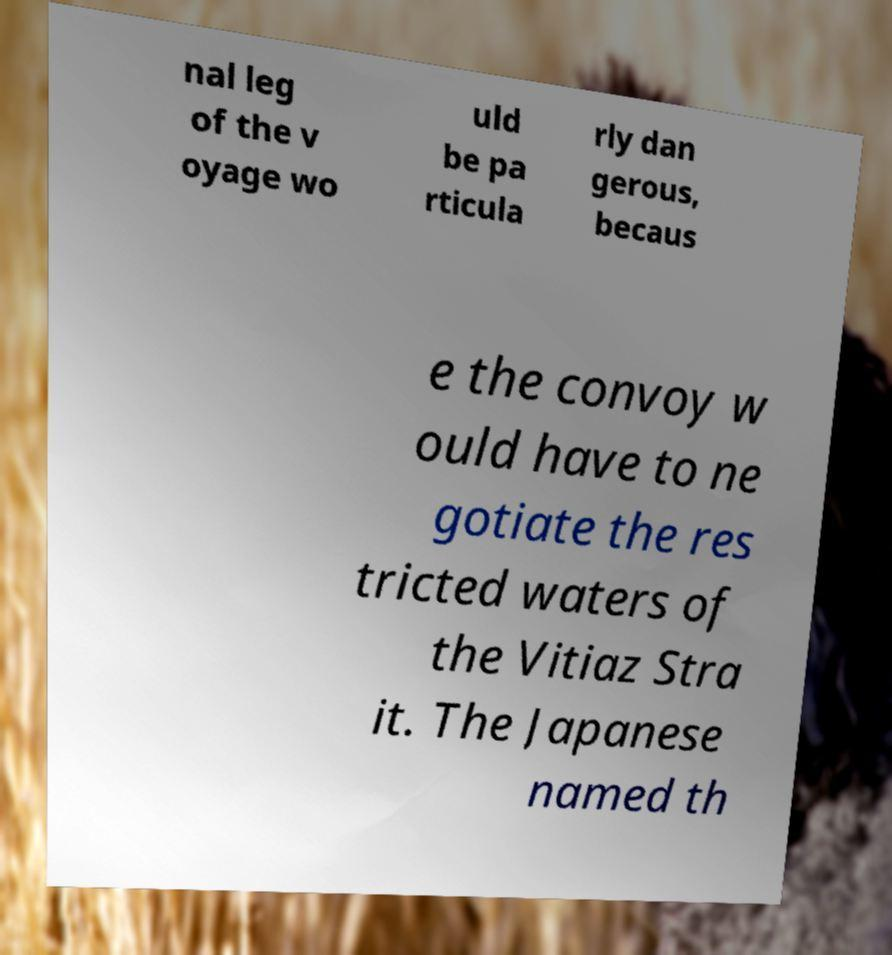Please read and relay the text visible in this image. What does it say? nal leg of the v oyage wo uld be pa rticula rly dan gerous, becaus e the convoy w ould have to ne gotiate the res tricted waters of the Vitiaz Stra it. The Japanese named th 